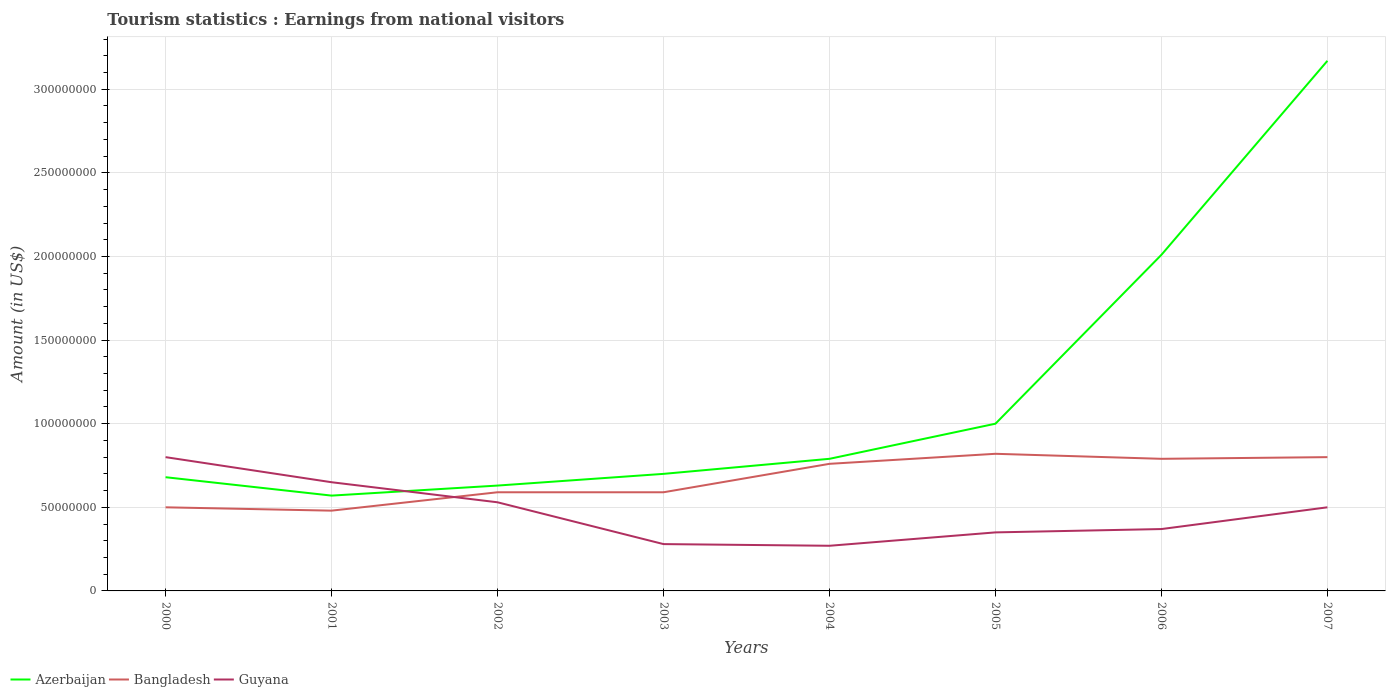Does the line corresponding to Bangladesh intersect with the line corresponding to Guyana?
Your answer should be compact. Yes. Is the number of lines equal to the number of legend labels?
Offer a very short reply. Yes. Across all years, what is the maximum earnings from national visitors in Bangladesh?
Offer a terse response. 4.80e+07. What is the total earnings from national visitors in Bangladesh in the graph?
Keep it short and to the point. 0. What is the difference between the highest and the second highest earnings from national visitors in Bangladesh?
Make the answer very short. 3.40e+07. What is the difference between the highest and the lowest earnings from national visitors in Azerbaijan?
Your answer should be compact. 2. Is the earnings from national visitors in Azerbaijan strictly greater than the earnings from national visitors in Bangladesh over the years?
Provide a succinct answer. No. How many lines are there?
Make the answer very short. 3. What is the difference between two consecutive major ticks on the Y-axis?
Make the answer very short. 5.00e+07. Are the values on the major ticks of Y-axis written in scientific E-notation?
Your response must be concise. No. Where does the legend appear in the graph?
Ensure brevity in your answer.  Bottom left. How many legend labels are there?
Your answer should be very brief. 3. What is the title of the graph?
Your answer should be very brief. Tourism statistics : Earnings from national visitors. What is the Amount (in US$) of Azerbaijan in 2000?
Your answer should be compact. 6.80e+07. What is the Amount (in US$) of Guyana in 2000?
Your response must be concise. 8.00e+07. What is the Amount (in US$) of Azerbaijan in 2001?
Keep it short and to the point. 5.70e+07. What is the Amount (in US$) in Bangladesh in 2001?
Your response must be concise. 4.80e+07. What is the Amount (in US$) of Guyana in 2001?
Make the answer very short. 6.50e+07. What is the Amount (in US$) in Azerbaijan in 2002?
Your answer should be compact. 6.30e+07. What is the Amount (in US$) of Bangladesh in 2002?
Ensure brevity in your answer.  5.90e+07. What is the Amount (in US$) of Guyana in 2002?
Offer a very short reply. 5.30e+07. What is the Amount (in US$) in Azerbaijan in 2003?
Offer a very short reply. 7.00e+07. What is the Amount (in US$) in Bangladesh in 2003?
Provide a succinct answer. 5.90e+07. What is the Amount (in US$) in Guyana in 2003?
Provide a short and direct response. 2.80e+07. What is the Amount (in US$) of Azerbaijan in 2004?
Offer a very short reply. 7.90e+07. What is the Amount (in US$) of Bangladesh in 2004?
Your response must be concise. 7.60e+07. What is the Amount (in US$) in Guyana in 2004?
Your answer should be compact. 2.70e+07. What is the Amount (in US$) in Azerbaijan in 2005?
Keep it short and to the point. 1.00e+08. What is the Amount (in US$) in Bangladesh in 2005?
Your response must be concise. 8.20e+07. What is the Amount (in US$) of Guyana in 2005?
Make the answer very short. 3.50e+07. What is the Amount (in US$) of Azerbaijan in 2006?
Provide a short and direct response. 2.01e+08. What is the Amount (in US$) in Bangladesh in 2006?
Your answer should be compact. 7.90e+07. What is the Amount (in US$) in Guyana in 2006?
Ensure brevity in your answer.  3.70e+07. What is the Amount (in US$) in Azerbaijan in 2007?
Provide a short and direct response. 3.17e+08. What is the Amount (in US$) of Bangladesh in 2007?
Keep it short and to the point. 8.00e+07. What is the Amount (in US$) in Guyana in 2007?
Provide a short and direct response. 5.00e+07. Across all years, what is the maximum Amount (in US$) in Azerbaijan?
Give a very brief answer. 3.17e+08. Across all years, what is the maximum Amount (in US$) of Bangladesh?
Offer a terse response. 8.20e+07. Across all years, what is the maximum Amount (in US$) in Guyana?
Your response must be concise. 8.00e+07. Across all years, what is the minimum Amount (in US$) in Azerbaijan?
Provide a short and direct response. 5.70e+07. Across all years, what is the minimum Amount (in US$) in Bangladesh?
Offer a terse response. 4.80e+07. Across all years, what is the minimum Amount (in US$) in Guyana?
Your answer should be very brief. 2.70e+07. What is the total Amount (in US$) in Azerbaijan in the graph?
Your answer should be very brief. 9.55e+08. What is the total Amount (in US$) in Bangladesh in the graph?
Give a very brief answer. 5.33e+08. What is the total Amount (in US$) of Guyana in the graph?
Provide a short and direct response. 3.75e+08. What is the difference between the Amount (in US$) in Azerbaijan in 2000 and that in 2001?
Offer a terse response. 1.10e+07. What is the difference between the Amount (in US$) in Bangladesh in 2000 and that in 2001?
Make the answer very short. 2.00e+06. What is the difference between the Amount (in US$) in Guyana in 2000 and that in 2001?
Give a very brief answer. 1.50e+07. What is the difference between the Amount (in US$) of Bangladesh in 2000 and that in 2002?
Offer a very short reply. -9.00e+06. What is the difference between the Amount (in US$) in Guyana in 2000 and that in 2002?
Make the answer very short. 2.70e+07. What is the difference between the Amount (in US$) of Bangladesh in 2000 and that in 2003?
Provide a succinct answer. -9.00e+06. What is the difference between the Amount (in US$) of Guyana in 2000 and that in 2003?
Provide a short and direct response. 5.20e+07. What is the difference between the Amount (in US$) in Azerbaijan in 2000 and that in 2004?
Your answer should be compact. -1.10e+07. What is the difference between the Amount (in US$) of Bangladesh in 2000 and that in 2004?
Your answer should be very brief. -2.60e+07. What is the difference between the Amount (in US$) in Guyana in 2000 and that in 2004?
Your response must be concise. 5.30e+07. What is the difference between the Amount (in US$) in Azerbaijan in 2000 and that in 2005?
Offer a terse response. -3.20e+07. What is the difference between the Amount (in US$) in Bangladesh in 2000 and that in 2005?
Make the answer very short. -3.20e+07. What is the difference between the Amount (in US$) of Guyana in 2000 and that in 2005?
Your answer should be very brief. 4.50e+07. What is the difference between the Amount (in US$) in Azerbaijan in 2000 and that in 2006?
Keep it short and to the point. -1.33e+08. What is the difference between the Amount (in US$) in Bangladesh in 2000 and that in 2006?
Give a very brief answer. -2.90e+07. What is the difference between the Amount (in US$) in Guyana in 2000 and that in 2006?
Your answer should be compact. 4.30e+07. What is the difference between the Amount (in US$) in Azerbaijan in 2000 and that in 2007?
Provide a succinct answer. -2.49e+08. What is the difference between the Amount (in US$) of Bangladesh in 2000 and that in 2007?
Your response must be concise. -3.00e+07. What is the difference between the Amount (in US$) in Guyana in 2000 and that in 2007?
Your answer should be very brief. 3.00e+07. What is the difference between the Amount (in US$) of Azerbaijan in 2001 and that in 2002?
Keep it short and to the point. -6.00e+06. What is the difference between the Amount (in US$) of Bangladesh in 2001 and that in 2002?
Your response must be concise. -1.10e+07. What is the difference between the Amount (in US$) of Guyana in 2001 and that in 2002?
Make the answer very short. 1.20e+07. What is the difference between the Amount (in US$) in Azerbaijan in 2001 and that in 2003?
Offer a terse response. -1.30e+07. What is the difference between the Amount (in US$) in Bangladesh in 2001 and that in 2003?
Keep it short and to the point. -1.10e+07. What is the difference between the Amount (in US$) of Guyana in 2001 and that in 2003?
Your response must be concise. 3.70e+07. What is the difference between the Amount (in US$) of Azerbaijan in 2001 and that in 2004?
Provide a succinct answer. -2.20e+07. What is the difference between the Amount (in US$) in Bangladesh in 2001 and that in 2004?
Your answer should be compact. -2.80e+07. What is the difference between the Amount (in US$) of Guyana in 2001 and that in 2004?
Give a very brief answer. 3.80e+07. What is the difference between the Amount (in US$) in Azerbaijan in 2001 and that in 2005?
Your answer should be compact. -4.30e+07. What is the difference between the Amount (in US$) in Bangladesh in 2001 and that in 2005?
Your answer should be compact. -3.40e+07. What is the difference between the Amount (in US$) in Guyana in 2001 and that in 2005?
Give a very brief answer. 3.00e+07. What is the difference between the Amount (in US$) in Azerbaijan in 2001 and that in 2006?
Make the answer very short. -1.44e+08. What is the difference between the Amount (in US$) in Bangladesh in 2001 and that in 2006?
Your response must be concise. -3.10e+07. What is the difference between the Amount (in US$) of Guyana in 2001 and that in 2006?
Offer a terse response. 2.80e+07. What is the difference between the Amount (in US$) in Azerbaijan in 2001 and that in 2007?
Keep it short and to the point. -2.60e+08. What is the difference between the Amount (in US$) of Bangladesh in 2001 and that in 2007?
Provide a short and direct response. -3.20e+07. What is the difference between the Amount (in US$) of Guyana in 2001 and that in 2007?
Your response must be concise. 1.50e+07. What is the difference between the Amount (in US$) of Azerbaijan in 2002 and that in 2003?
Provide a succinct answer. -7.00e+06. What is the difference between the Amount (in US$) of Guyana in 2002 and that in 2003?
Offer a terse response. 2.50e+07. What is the difference between the Amount (in US$) of Azerbaijan in 2002 and that in 2004?
Your answer should be very brief. -1.60e+07. What is the difference between the Amount (in US$) of Bangladesh in 2002 and that in 2004?
Give a very brief answer. -1.70e+07. What is the difference between the Amount (in US$) of Guyana in 2002 and that in 2004?
Keep it short and to the point. 2.60e+07. What is the difference between the Amount (in US$) of Azerbaijan in 2002 and that in 2005?
Keep it short and to the point. -3.70e+07. What is the difference between the Amount (in US$) in Bangladesh in 2002 and that in 2005?
Your answer should be compact. -2.30e+07. What is the difference between the Amount (in US$) of Guyana in 2002 and that in 2005?
Your answer should be very brief. 1.80e+07. What is the difference between the Amount (in US$) of Azerbaijan in 2002 and that in 2006?
Provide a short and direct response. -1.38e+08. What is the difference between the Amount (in US$) in Bangladesh in 2002 and that in 2006?
Provide a succinct answer. -2.00e+07. What is the difference between the Amount (in US$) in Guyana in 2002 and that in 2006?
Your answer should be compact. 1.60e+07. What is the difference between the Amount (in US$) of Azerbaijan in 2002 and that in 2007?
Ensure brevity in your answer.  -2.54e+08. What is the difference between the Amount (in US$) of Bangladesh in 2002 and that in 2007?
Ensure brevity in your answer.  -2.10e+07. What is the difference between the Amount (in US$) in Guyana in 2002 and that in 2007?
Ensure brevity in your answer.  3.00e+06. What is the difference between the Amount (in US$) of Azerbaijan in 2003 and that in 2004?
Provide a succinct answer. -9.00e+06. What is the difference between the Amount (in US$) in Bangladesh in 2003 and that in 2004?
Your response must be concise. -1.70e+07. What is the difference between the Amount (in US$) in Azerbaijan in 2003 and that in 2005?
Your response must be concise. -3.00e+07. What is the difference between the Amount (in US$) of Bangladesh in 2003 and that in 2005?
Make the answer very short. -2.30e+07. What is the difference between the Amount (in US$) of Guyana in 2003 and that in 2005?
Your answer should be very brief. -7.00e+06. What is the difference between the Amount (in US$) of Azerbaijan in 2003 and that in 2006?
Offer a terse response. -1.31e+08. What is the difference between the Amount (in US$) in Bangladesh in 2003 and that in 2006?
Provide a succinct answer. -2.00e+07. What is the difference between the Amount (in US$) in Guyana in 2003 and that in 2006?
Keep it short and to the point. -9.00e+06. What is the difference between the Amount (in US$) in Azerbaijan in 2003 and that in 2007?
Your response must be concise. -2.47e+08. What is the difference between the Amount (in US$) in Bangladesh in 2003 and that in 2007?
Your response must be concise. -2.10e+07. What is the difference between the Amount (in US$) in Guyana in 2003 and that in 2007?
Make the answer very short. -2.20e+07. What is the difference between the Amount (in US$) in Azerbaijan in 2004 and that in 2005?
Keep it short and to the point. -2.10e+07. What is the difference between the Amount (in US$) in Bangladesh in 2004 and that in 2005?
Provide a succinct answer. -6.00e+06. What is the difference between the Amount (in US$) of Guyana in 2004 and that in 2005?
Keep it short and to the point. -8.00e+06. What is the difference between the Amount (in US$) in Azerbaijan in 2004 and that in 2006?
Ensure brevity in your answer.  -1.22e+08. What is the difference between the Amount (in US$) of Bangladesh in 2004 and that in 2006?
Your response must be concise. -3.00e+06. What is the difference between the Amount (in US$) of Guyana in 2004 and that in 2006?
Make the answer very short. -1.00e+07. What is the difference between the Amount (in US$) of Azerbaijan in 2004 and that in 2007?
Provide a succinct answer. -2.38e+08. What is the difference between the Amount (in US$) of Guyana in 2004 and that in 2007?
Give a very brief answer. -2.30e+07. What is the difference between the Amount (in US$) of Azerbaijan in 2005 and that in 2006?
Offer a very short reply. -1.01e+08. What is the difference between the Amount (in US$) of Guyana in 2005 and that in 2006?
Offer a very short reply. -2.00e+06. What is the difference between the Amount (in US$) of Azerbaijan in 2005 and that in 2007?
Provide a short and direct response. -2.17e+08. What is the difference between the Amount (in US$) of Guyana in 2005 and that in 2007?
Offer a terse response. -1.50e+07. What is the difference between the Amount (in US$) of Azerbaijan in 2006 and that in 2007?
Your response must be concise. -1.16e+08. What is the difference between the Amount (in US$) in Guyana in 2006 and that in 2007?
Make the answer very short. -1.30e+07. What is the difference between the Amount (in US$) in Bangladesh in 2000 and the Amount (in US$) in Guyana in 2001?
Give a very brief answer. -1.50e+07. What is the difference between the Amount (in US$) of Azerbaijan in 2000 and the Amount (in US$) of Bangladesh in 2002?
Keep it short and to the point. 9.00e+06. What is the difference between the Amount (in US$) in Azerbaijan in 2000 and the Amount (in US$) in Guyana in 2002?
Provide a succinct answer. 1.50e+07. What is the difference between the Amount (in US$) of Azerbaijan in 2000 and the Amount (in US$) of Bangladesh in 2003?
Give a very brief answer. 9.00e+06. What is the difference between the Amount (in US$) in Azerbaijan in 2000 and the Amount (in US$) in Guyana in 2003?
Offer a terse response. 4.00e+07. What is the difference between the Amount (in US$) in Bangladesh in 2000 and the Amount (in US$) in Guyana in 2003?
Offer a terse response. 2.20e+07. What is the difference between the Amount (in US$) in Azerbaijan in 2000 and the Amount (in US$) in Bangladesh in 2004?
Ensure brevity in your answer.  -8.00e+06. What is the difference between the Amount (in US$) in Azerbaijan in 2000 and the Amount (in US$) in Guyana in 2004?
Your response must be concise. 4.10e+07. What is the difference between the Amount (in US$) in Bangladesh in 2000 and the Amount (in US$) in Guyana in 2004?
Make the answer very short. 2.30e+07. What is the difference between the Amount (in US$) of Azerbaijan in 2000 and the Amount (in US$) of Bangladesh in 2005?
Offer a very short reply. -1.40e+07. What is the difference between the Amount (in US$) of Azerbaijan in 2000 and the Amount (in US$) of Guyana in 2005?
Make the answer very short. 3.30e+07. What is the difference between the Amount (in US$) in Bangladesh in 2000 and the Amount (in US$) in Guyana in 2005?
Offer a very short reply. 1.50e+07. What is the difference between the Amount (in US$) in Azerbaijan in 2000 and the Amount (in US$) in Bangladesh in 2006?
Provide a succinct answer. -1.10e+07. What is the difference between the Amount (in US$) in Azerbaijan in 2000 and the Amount (in US$) in Guyana in 2006?
Ensure brevity in your answer.  3.10e+07. What is the difference between the Amount (in US$) in Bangladesh in 2000 and the Amount (in US$) in Guyana in 2006?
Your response must be concise. 1.30e+07. What is the difference between the Amount (in US$) in Azerbaijan in 2000 and the Amount (in US$) in Bangladesh in 2007?
Give a very brief answer. -1.20e+07. What is the difference between the Amount (in US$) of Azerbaijan in 2000 and the Amount (in US$) of Guyana in 2007?
Offer a very short reply. 1.80e+07. What is the difference between the Amount (in US$) in Bangladesh in 2000 and the Amount (in US$) in Guyana in 2007?
Give a very brief answer. 0. What is the difference between the Amount (in US$) of Bangladesh in 2001 and the Amount (in US$) of Guyana in 2002?
Provide a succinct answer. -5.00e+06. What is the difference between the Amount (in US$) of Azerbaijan in 2001 and the Amount (in US$) of Bangladesh in 2003?
Offer a terse response. -2.00e+06. What is the difference between the Amount (in US$) in Azerbaijan in 2001 and the Amount (in US$) in Guyana in 2003?
Your answer should be compact. 2.90e+07. What is the difference between the Amount (in US$) in Bangladesh in 2001 and the Amount (in US$) in Guyana in 2003?
Your response must be concise. 2.00e+07. What is the difference between the Amount (in US$) of Azerbaijan in 2001 and the Amount (in US$) of Bangladesh in 2004?
Provide a short and direct response. -1.90e+07. What is the difference between the Amount (in US$) of Azerbaijan in 2001 and the Amount (in US$) of Guyana in 2004?
Make the answer very short. 3.00e+07. What is the difference between the Amount (in US$) in Bangladesh in 2001 and the Amount (in US$) in Guyana in 2004?
Make the answer very short. 2.10e+07. What is the difference between the Amount (in US$) in Azerbaijan in 2001 and the Amount (in US$) in Bangladesh in 2005?
Your answer should be very brief. -2.50e+07. What is the difference between the Amount (in US$) of Azerbaijan in 2001 and the Amount (in US$) of Guyana in 2005?
Provide a succinct answer. 2.20e+07. What is the difference between the Amount (in US$) of Bangladesh in 2001 and the Amount (in US$) of Guyana in 2005?
Provide a short and direct response. 1.30e+07. What is the difference between the Amount (in US$) in Azerbaijan in 2001 and the Amount (in US$) in Bangladesh in 2006?
Provide a short and direct response. -2.20e+07. What is the difference between the Amount (in US$) of Bangladesh in 2001 and the Amount (in US$) of Guyana in 2006?
Make the answer very short. 1.10e+07. What is the difference between the Amount (in US$) of Azerbaijan in 2001 and the Amount (in US$) of Bangladesh in 2007?
Provide a succinct answer. -2.30e+07. What is the difference between the Amount (in US$) in Azerbaijan in 2002 and the Amount (in US$) in Bangladesh in 2003?
Offer a terse response. 4.00e+06. What is the difference between the Amount (in US$) of Azerbaijan in 2002 and the Amount (in US$) of Guyana in 2003?
Your answer should be very brief. 3.50e+07. What is the difference between the Amount (in US$) in Bangladesh in 2002 and the Amount (in US$) in Guyana in 2003?
Your response must be concise. 3.10e+07. What is the difference between the Amount (in US$) in Azerbaijan in 2002 and the Amount (in US$) in Bangladesh in 2004?
Give a very brief answer. -1.30e+07. What is the difference between the Amount (in US$) of Azerbaijan in 2002 and the Amount (in US$) of Guyana in 2004?
Your answer should be very brief. 3.60e+07. What is the difference between the Amount (in US$) in Bangladesh in 2002 and the Amount (in US$) in Guyana in 2004?
Give a very brief answer. 3.20e+07. What is the difference between the Amount (in US$) in Azerbaijan in 2002 and the Amount (in US$) in Bangladesh in 2005?
Provide a short and direct response. -1.90e+07. What is the difference between the Amount (in US$) of Azerbaijan in 2002 and the Amount (in US$) of Guyana in 2005?
Provide a short and direct response. 2.80e+07. What is the difference between the Amount (in US$) of Bangladesh in 2002 and the Amount (in US$) of Guyana in 2005?
Your answer should be very brief. 2.40e+07. What is the difference between the Amount (in US$) of Azerbaijan in 2002 and the Amount (in US$) of Bangladesh in 2006?
Offer a terse response. -1.60e+07. What is the difference between the Amount (in US$) in Azerbaijan in 2002 and the Amount (in US$) in Guyana in 2006?
Provide a succinct answer. 2.60e+07. What is the difference between the Amount (in US$) in Bangladesh in 2002 and the Amount (in US$) in Guyana in 2006?
Your response must be concise. 2.20e+07. What is the difference between the Amount (in US$) in Azerbaijan in 2002 and the Amount (in US$) in Bangladesh in 2007?
Your answer should be very brief. -1.70e+07. What is the difference between the Amount (in US$) of Azerbaijan in 2002 and the Amount (in US$) of Guyana in 2007?
Provide a short and direct response. 1.30e+07. What is the difference between the Amount (in US$) of Bangladesh in 2002 and the Amount (in US$) of Guyana in 2007?
Provide a succinct answer. 9.00e+06. What is the difference between the Amount (in US$) of Azerbaijan in 2003 and the Amount (in US$) of Bangladesh in 2004?
Make the answer very short. -6.00e+06. What is the difference between the Amount (in US$) of Azerbaijan in 2003 and the Amount (in US$) of Guyana in 2004?
Your answer should be compact. 4.30e+07. What is the difference between the Amount (in US$) of Bangladesh in 2003 and the Amount (in US$) of Guyana in 2004?
Provide a succinct answer. 3.20e+07. What is the difference between the Amount (in US$) of Azerbaijan in 2003 and the Amount (in US$) of Bangladesh in 2005?
Keep it short and to the point. -1.20e+07. What is the difference between the Amount (in US$) of Azerbaijan in 2003 and the Amount (in US$) of Guyana in 2005?
Keep it short and to the point. 3.50e+07. What is the difference between the Amount (in US$) of Bangladesh in 2003 and the Amount (in US$) of Guyana in 2005?
Give a very brief answer. 2.40e+07. What is the difference between the Amount (in US$) of Azerbaijan in 2003 and the Amount (in US$) of Bangladesh in 2006?
Provide a short and direct response. -9.00e+06. What is the difference between the Amount (in US$) of Azerbaijan in 2003 and the Amount (in US$) of Guyana in 2006?
Provide a short and direct response. 3.30e+07. What is the difference between the Amount (in US$) in Bangladesh in 2003 and the Amount (in US$) in Guyana in 2006?
Your answer should be very brief. 2.20e+07. What is the difference between the Amount (in US$) in Azerbaijan in 2003 and the Amount (in US$) in Bangladesh in 2007?
Ensure brevity in your answer.  -1.00e+07. What is the difference between the Amount (in US$) in Bangladesh in 2003 and the Amount (in US$) in Guyana in 2007?
Provide a short and direct response. 9.00e+06. What is the difference between the Amount (in US$) in Azerbaijan in 2004 and the Amount (in US$) in Guyana in 2005?
Keep it short and to the point. 4.40e+07. What is the difference between the Amount (in US$) of Bangladesh in 2004 and the Amount (in US$) of Guyana in 2005?
Your response must be concise. 4.10e+07. What is the difference between the Amount (in US$) of Azerbaijan in 2004 and the Amount (in US$) of Guyana in 2006?
Offer a terse response. 4.20e+07. What is the difference between the Amount (in US$) of Bangladesh in 2004 and the Amount (in US$) of Guyana in 2006?
Your answer should be very brief. 3.90e+07. What is the difference between the Amount (in US$) in Azerbaijan in 2004 and the Amount (in US$) in Bangladesh in 2007?
Ensure brevity in your answer.  -1.00e+06. What is the difference between the Amount (in US$) in Azerbaijan in 2004 and the Amount (in US$) in Guyana in 2007?
Keep it short and to the point. 2.90e+07. What is the difference between the Amount (in US$) of Bangladesh in 2004 and the Amount (in US$) of Guyana in 2007?
Offer a terse response. 2.60e+07. What is the difference between the Amount (in US$) of Azerbaijan in 2005 and the Amount (in US$) of Bangladesh in 2006?
Provide a succinct answer. 2.10e+07. What is the difference between the Amount (in US$) of Azerbaijan in 2005 and the Amount (in US$) of Guyana in 2006?
Your answer should be compact. 6.30e+07. What is the difference between the Amount (in US$) of Bangladesh in 2005 and the Amount (in US$) of Guyana in 2006?
Give a very brief answer. 4.50e+07. What is the difference between the Amount (in US$) in Azerbaijan in 2005 and the Amount (in US$) in Bangladesh in 2007?
Ensure brevity in your answer.  2.00e+07. What is the difference between the Amount (in US$) in Azerbaijan in 2005 and the Amount (in US$) in Guyana in 2007?
Offer a very short reply. 5.00e+07. What is the difference between the Amount (in US$) in Bangladesh in 2005 and the Amount (in US$) in Guyana in 2007?
Offer a terse response. 3.20e+07. What is the difference between the Amount (in US$) in Azerbaijan in 2006 and the Amount (in US$) in Bangladesh in 2007?
Your response must be concise. 1.21e+08. What is the difference between the Amount (in US$) of Azerbaijan in 2006 and the Amount (in US$) of Guyana in 2007?
Offer a terse response. 1.51e+08. What is the difference between the Amount (in US$) of Bangladesh in 2006 and the Amount (in US$) of Guyana in 2007?
Give a very brief answer. 2.90e+07. What is the average Amount (in US$) of Azerbaijan per year?
Offer a terse response. 1.19e+08. What is the average Amount (in US$) of Bangladesh per year?
Offer a very short reply. 6.66e+07. What is the average Amount (in US$) of Guyana per year?
Your response must be concise. 4.69e+07. In the year 2000, what is the difference between the Amount (in US$) in Azerbaijan and Amount (in US$) in Bangladesh?
Ensure brevity in your answer.  1.80e+07. In the year 2000, what is the difference between the Amount (in US$) in Azerbaijan and Amount (in US$) in Guyana?
Your answer should be compact. -1.20e+07. In the year 2000, what is the difference between the Amount (in US$) in Bangladesh and Amount (in US$) in Guyana?
Your response must be concise. -3.00e+07. In the year 2001, what is the difference between the Amount (in US$) of Azerbaijan and Amount (in US$) of Bangladesh?
Your answer should be compact. 9.00e+06. In the year 2001, what is the difference between the Amount (in US$) of Azerbaijan and Amount (in US$) of Guyana?
Give a very brief answer. -8.00e+06. In the year 2001, what is the difference between the Amount (in US$) of Bangladesh and Amount (in US$) of Guyana?
Ensure brevity in your answer.  -1.70e+07. In the year 2002, what is the difference between the Amount (in US$) of Azerbaijan and Amount (in US$) of Guyana?
Your answer should be compact. 1.00e+07. In the year 2002, what is the difference between the Amount (in US$) of Bangladesh and Amount (in US$) of Guyana?
Give a very brief answer. 6.00e+06. In the year 2003, what is the difference between the Amount (in US$) in Azerbaijan and Amount (in US$) in Bangladesh?
Your answer should be very brief. 1.10e+07. In the year 2003, what is the difference between the Amount (in US$) in Azerbaijan and Amount (in US$) in Guyana?
Provide a short and direct response. 4.20e+07. In the year 2003, what is the difference between the Amount (in US$) in Bangladesh and Amount (in US$) in Guyana?
Offer a terse response. 3.10e+07. In the year 2004, what is the difference between the Amount (in US$) in Azerbaijan and Amount (in US$) in Guyana?
Make the answer very short. 5.20e+07. In the year 2004, what is the difference between the Amount (in US$) in Bangladesh and Amount (in US$) in Guyana?
Ensure brevity in your answer.  4.90e+07. In the year 2005, what is the difference between the Amount (in US$) of Azerbaijan and Amount (in US$) of Bangladesh?
Your answer should be compact. 1.80e+07. In the year 2005, what is the difference between the Amount (in US$) in Azerbaijan and Amount (in US$) in Guyana?
Your answer should be compact. 6.50e+07. In the year 2005, what is the difference between the Amount (in US$) of Bangladesh and Amount (in US$) of Guyana?
Offer a very short reply. 4.70e+07. In the year 2006, what is the difference between the Amount (in US$) of Azerbaijan and Amount (in US$) of Bangladesh?
Your answer should be very brief. 1.22e+08. In the year 2006, what is the difference between the Amount (in US$) of Azerbaijan and Amount (in US$) of Guyana?
Provide a succinct answer. 1.64e+08. In the year 2006, what is the difference between the Amount (in US$) of Bangladesh and Amount (in US$) of Guyana?
Offer a terse response. 4.20e+07. In the year 2007, what is the difference between the Amount (in US$) in Azerbaijan and Amount (in US$) in Bangladesh?
Provide a succinct answer. 2.37e+08. In the year 2007, what is the difference between the Amount (in US$) of Azerbaijan and Amount (in US$) of Guyana?
Provide a succinct answer. 2.67e+08. In the year 2007, what is the difference between the Amount (in US$) of Bangladesh and Amount (in US$) of Guyana?
Offer a terse response. 3.00e+07. What is the ratio of the Amount (in US$) of Azerbaijan in 2000 to that in 2001?
Ensure brevity in your answer.  1.19. What is the ratio of the Amount (in US$) in Bangladesh in 2000 to that in 2001?
Offer a terse response. 1.04. What is the ratio of the Amount (in US$) of Guyana in 2000 to that in 2001?
Keep it short and to the point. 1.23. What is the ratio of the Amount (in US$) of Azerbaijan in 2000 to that in 2002?
Make the answer very short. 1.08. What is the ratio of the Amount (in US$) of Bangladesh in 2000 to that in 2002?
Offer a very short reply. 0.85. What is the ratio of the Amount (in US$) of Guyana in 2000 to that in 2002?
Keep it short and to the point. 1.51. What is the ratio of the Amount (in US$) in Azerbaijan in 2000 to that in 2003?
Make the answer very short. 0.97. What is the ratio of the Amount (in US$) in Bangladesh in 2000 to that in 2003?
Offer a very short reply. 0.85. What is the ratio of the Amount (in US$) of Guyana in 2000 to that in 2003?
Provide a succinct answer. 2.86. What is the ratio of the Amount (in US$) in Azerbaijan in 2000 to that in 2004?
Offer a terse response. 0.86. What is the ratio of the Amount (in US$) of Bangladesh in 2000 to that in 2004?
Give a very brief answer. 0.66. What is the ratio of the Amount (in US$) of Guyana in 2000 to that in 2004?
Offer a terse response. 2.96. What is the ratio of the Amount (in US$) of Azerbaijan in 2000 to that in 2005?
Make the answer very short. 0.68. What is the ratio of the Amount (in US$) of Bangladesh in 2000 to that in 2005?
Your answer should be compact. 0.61. What is the ratio of the Amount (in US$) in Guyana in 2000 to that in 2005?
Your answer should be very brief. 2.29. What is the ratio of the Amount (in US$) in Azerbaijan in 2000 to that in 2006?
Ensure brevity in your answer.  0.34. What is the ratio of the Amount (in US$) in Bangladesh in 2000 to that in 2006?
Your answer should be very brief. 0.63. What is the ratio of the Amount (in US$) of Guyana in 2000 to that in 2006?
Your answer should be compact. 2.16. What is the ratio of the Amount (in US$) of Azerbaijan in 2000 to that in 2007?
Offer a very short reply. 0.21. What is the ratio of the Amount (in US$) in Bangladesh in 2000 to that in 2007?
Your answer should be very brief. 0.62. What is the ratio of the Amount (in US$) in Azerbaijan in 2001 to that in 2002?
Make the answer very short. 0.9. What is the ratio of the Amount (in US$) of Bangladesh in 2001 to that in 2002?
Offer a terse response. 0.81. What is the ratio of the Amount (in US$) of Guyana in 2001 to that in 2002?
Your response must be concise. 1.23. What is the ratio of the Amount (in US$) in Azerbaijan in 2001 to that in 2003?
Provide a short and direct response. 0.81. What is the ratio of the Amount (in US$) in Bangladesh in 2001 to that in 2003?
Keep it short and to the point. 0.81. What is the ratio of the Amount (in US$) of Guyana in 2001 to that in 2003?
Provide a short and direct response. 2.32. What is the ratio of the Amount (in US$) of Azerbaijan in 2001 to that in 2004?
Provide a succinct answer. 0.72. What is the ratio of the Amount (in US$) of Bangladesh in 2001 to that in 2004?
Offer a terse response. 0.63. What is the ratio of the Amount (in US$) in Guyana in 2001 to that in 2004?
Ensure brevity in your answer.  2.41. What is the ratio of the Amount (in US$) of Azerbaijan in 2001 to that in 2005?
Your answer should be very brief. 0.57. What is the ratio of the Amount (in US$) in Bangladesh in 2001 to that in 2005?
Your response must be concise. 0.59. What is the ratio of the Amount (in US$) of Guyana in 2001 to that in 2005?
Your answer should be very brief. 1.86. What is the ratio of the Amount (in US$) of Azerbaijan in 2001 to that in 2006?
Provide a succinct answer. 0.28. What is the ratio of the Amount (in US$) in Bangladesh in 2001 to that in 2006?
Offer a terse response. 0.61. What is the ratio of the Amount (in US$) of Guyana in 2001 to that in 2006?
Your answer should be very brief. 1.76. What is the ratio of the Amount (in US$) in Azerbaijan in 2001 to that in 2007?
Your answer should be compact. 0.18. What is the ratio of the Amount (in US$) of Azerbaijan in 2002 to that in 2003?
Give a very brief answer. 0.9. What is the ratio of the Amount (in US$) of Bangladesh in 2002 to that in 2003?
Keep it short and to the point. 1. What is the ratio of the Amount (in US$) in Guyana in 2002 to that in 2003?
Offer a terse response. 1.89. What is the ratio of the Amount (in US$) of Azerbaijan in 2002 to that in 2004?
Offer a very short reply. 0.8. What is the ratio of the Amount (in US$) in Bangladesh in 2002 to that in 2004?
Offer a very short reply. 0.78. What is the ratio of the Amount (in US$) in Guyana in 2002 to that in 2004?
Offer a terse response. 1.96. What is the ratio of the Amount (in US$) in Azerbaijan in 2002 to that in 2005?
Ensure brevity in your answer.  0.63. What is the ratio of the Amount (in US$) in Bangladesh in 2002 to that in 2005?
Your answer should be very brief. 0.72. What is the ratio of the Amount (in US$) of Guyana in 2002 to that in 2005?
Offer a terse response. 1.51. What is the ratio of the Amount (in US$) in Azerbaijan in 2002 to that in 2006?
Your response must be concise. 0.31. What is the ratio of the Amount (in US$) in Bangladesh in 2002 to that in 2006?
Your response must be concise. 0.75. What is the ratio of the Amount (in US$) of Guyana in 2002 to that in 2006?
Make the answer very short. 1.43. What is the ratio of the Amount (in US$) in Azerbaijan in 2002 to that in 2007?
Your answer should be compact. 0.2. What is the ratio of the Amount (in US$) of Bangladesh in 2002 to that in 2007?
Your answer should be compact. 0.74. What is the ratio of the Amount (in US$) of Guyana in 2002 to that in 2007?
Give a very brief answer. 1.06. What is the ratio of the Amount (in US$) in Azerbaijan in 2003 to that in 2004?
Your answer should be compact. 0.89. What is the ratio of the Amount (in US$) of Bangladesh in 2003 to that in 2004?
Provide a short and direct response. 0.78. What is the ratio of the Amount (in US$) of Bangladesh in 2003 to that in 2005?
Your response must be concise. 0.72. What is the ratio of the Amount (in US$) in Guyana in 2003 to that in 2005?
Keep it short and to the point. 0.8. What is the ratio of the Amount (in US$) in Azerbaijan in 2003 to that in 2006?
Make the answer very short. 0.35. What is the ratio of the Amount (in US$) of Bangladesh in 2003 to that in 2006?
Your answer should be very brief. 0.75. What is the ratio of the Amount (in US$) in Guyana in 2003 to that in 2006?
Make the answer very short. 0.76. What is the ratio of the Amount (in US$) of Azerbaijan in 2003 to that in 2007?
Make the answer very short. 0.22. What is the ratio of the Amount (in US$) of Bangladesh in 2003 to that in 2007?
Provide a short and direct response. 0.74. What is the ratio of the Amount (in US$) of Guyana in 2003 to that in 2007?
Ensure brevity in your answer.  0.56. What is the ratio of the Amount (in US$) of Azerbaijan in 2004 to that in 2005?
Give a very brief answer. 0.79. What is the ratio of the Amount (in US$) of Bangladesh in 2004 to that in 2005?
Offer a terse response. 0.93. What is the ratio of the Amount (in US$) of Guyana in 2004 to that in 2005?
Give a very brief answer. 0.77. What is the ratio of the Amount (in US$) in Azerbaijan in 2004 to that in 2006?
Offer a terse response. 0.39. What is the ratio of the Amount (in US$) in Bangladesh in 2004 to that in 2006?
Your answer should be very brief. 0.96. What is the ratio of the Amount (in US$) of Guyana in 2004 to that in 2006?
Your answer should be compact. 0.73. What is the ratio of the Amount (in US$) of Azerbaijan in 2004 to that in 2007?
Provide a short and direct response. 0.25. What is the ratio of the Amount (in US$) of Bangladesh in 2004 to that in 2007?
Your answer should be very brief. 0.95. What is the ratio of the Amount (in US$) of Guyana in 2004 to that in 2007?
Keep it short and to the point. 0.54. What is the ratio of the Amount (in US$) of Azerbaijan in 2005 to that in 2006?
Ensure brevity in your answer.  0.5. What is the ratio of the Amount (in US$) of Bangladesh in 2005 to that in 2006?
Give a very brief answer. 1.04. What is the ratio of the Amount (in US$) in Guyana in 2005 to that in 2006?
Your answer should be very brief. 0.95. What is the ratio of the Amount (in US$) in Azerbaijan in 2005 to that in 2007?
Your answer should be very brief. 0.32. What is the ratio of the Amount (in US$) of Guyana in 2005 to that in 2007?
Make the answer very short. 0.7. What is the ratio of the Amount (in US$) in Azerbaijan in 2006 to that in 2007?
Give a very brief answer. 0.63. What is the ratio of the Amount (in US$) of Bangladesh in 2006 to that in 2007?
Offer a very short reply. 0.99. What is the ratio of the Amount (in US$) in Guyana in 2006 to that in 2007?
Provide a succinct answer. 0.74. What is the difference between the highest and the second highest Amount (in US$) in Azerbaijan?
Provide a short and direct response. 1.16e+08. What is the difference between the highest and the second highest Amount (in US$) in Bangladesh?
Provide a succinct answer. 2.00e+06. What is the difference between the highest and the second highest Amount (in US$) of Guyana?
Provide a short and direct response. 1.50e+07. What is the difference between the highest and the lowest Amount (in US$) of Azerbaijan?
Give a very brief answer. 2.60e+08. What is the difference between the highest and the lowest Amount (in US$) of Bangladesh?
Provide a short and direct response. 3.40e+07. What is the difference between the highest and the lowest Amount (in US$) in Guyana?
Make the answer very short. 5.30e+07. 